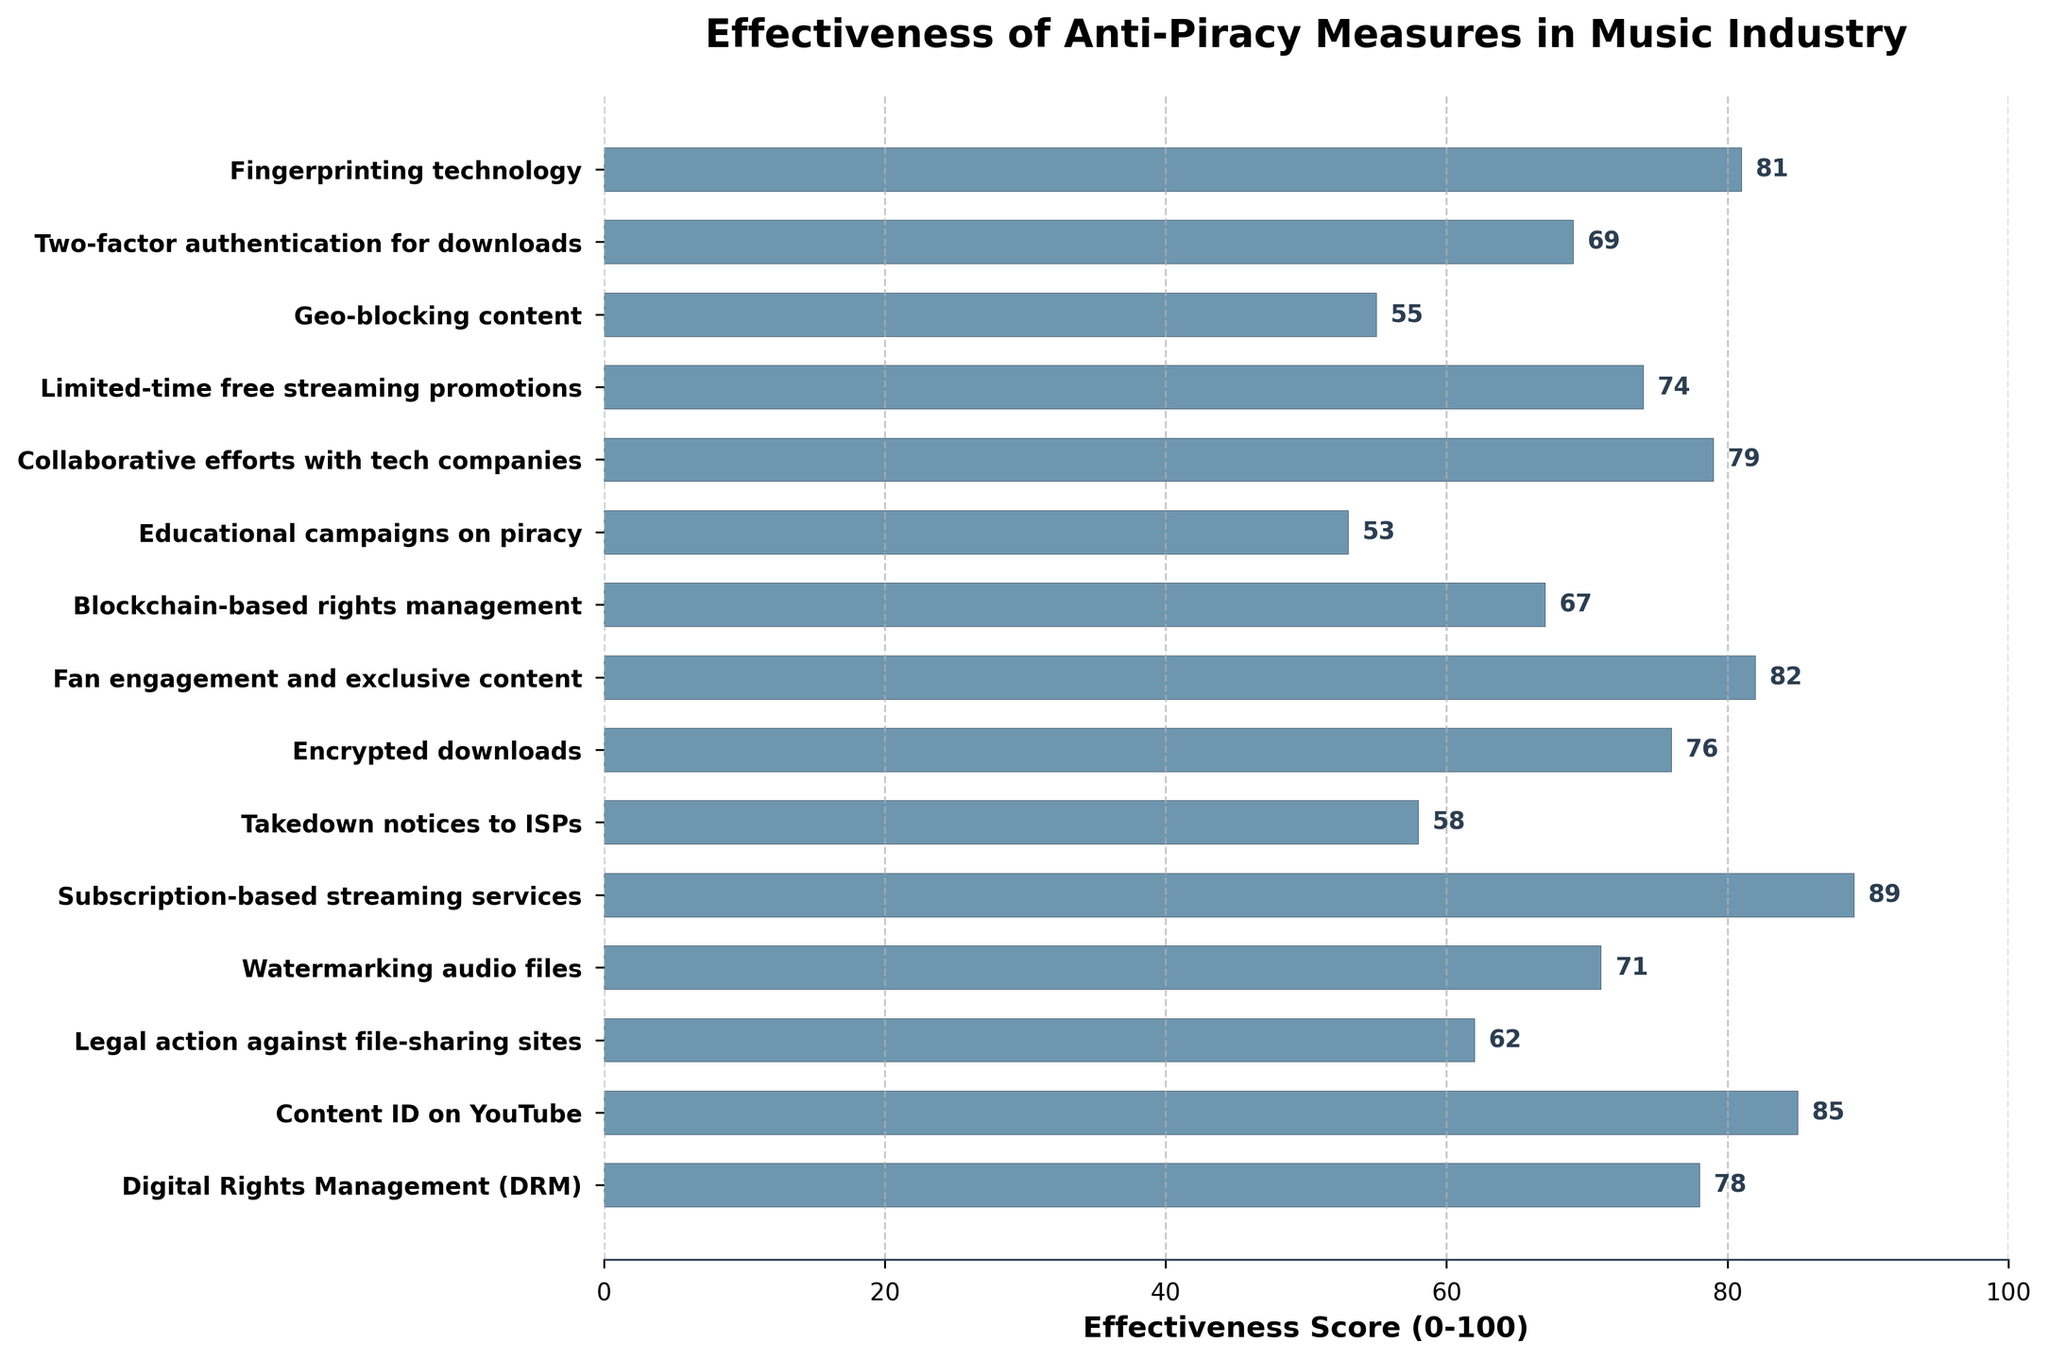What's the most effective anti-piracy measure according to the chart? The bar representing 'Subscription-based streaming services' reaches the highest point on the effectiveness scale, indicating it scored the highest effectiveness score of 89.
Answer: Subscription-based streaming services Which measure is the least effective? The bar for 'Educational campaigns on piracy' has the lowest height, corresponding to an effectiveness score of 53.
Answer: Educational campaigns on piracy How much more effective are 'Content ID on YouTube' measures compared to 'Takedown notices to ISPs'? 'Content ID on YouTube' has a score of 85, and 'Takedown notices to ISPs' has a score of 58. The difference is 85 - 58 = 27.
Answer: 27 What is the average effectiveness score of measures that scored above 70? To calculate the average, sum the effectiveness scores of measures above 70: (78 + 85 + 71 + 89 + 76 + 82 + 79 + 81 + 74 + 69) = 704. There are 10 such measures, so the average is 704 / 10 = 70.4.
Answer: 70.4 Which two measures have the closest effectiveness scores, and what is the difference between them? 'Blockchain-based rights management' and 'Two-factor authentication for downloads' have scores of 67 and 69, respectively. The difference is 69 - 67 = 2.
Answer: Blockchain-based rights management and Two-factor authentication for downloads, 2 Is 'Geo-blocking content' more effective than 'Educational campaigns on piracy'? By comparing the heights of the bars, 'Geo-blocking content' has a score of 55, which is higher than 'Educational campaigns on piracy' with a score of 53, indicating it's more effective.
Answer: Yes By how much does 'Digital Rights Management (DRM)' score differ from 'Collaborative efforts with tech companies'? 'Digital Rights Management' has a score of 78, while 'Collaborative efforts with tech companies' has a score of 79. The difference is 79 - 78 = 1.
Answer: 1 Which measure has a higher effectiveness score: 'Fan engagement and exclusive content' or 'Fingerprinting technology'? 'Fingerprinting technology' has an effectiveness score of 81, which is lower than 'Fan engagement and exclusive content' with a score of 82.
Answer: Fan engagement and exclusive content What is the total effectiveness score for 'Takedown notices to ISPs,' 'Geo-blocking content,' and 'Educational campaigns on piracy'? Summing the effectiveness scores: 58 (Takedown notices to ISPs) + 55 (Geo-blocking content) + 53 (Educational campaigns on piracy) gives a total of 166.
Answer: 166 